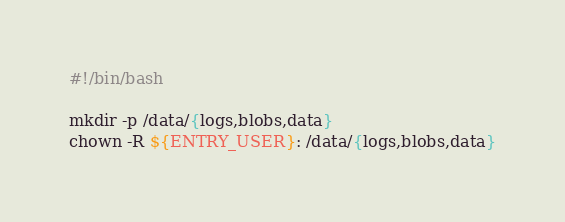<code> <loc_0><loc_0><loc_500><loc_500><_Bash_>#!/bin/bash

mkdir -p /data/{logs,blobs,data}
chown -R ${ENTRY_USER}: /data/{logs,blobs,data}
</code> 